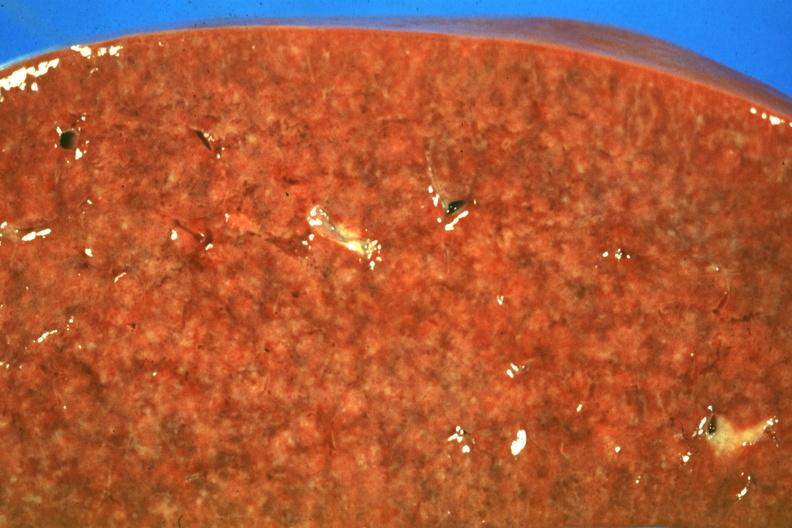does ameloblastoma show cut surface granulomas faint but there?
Answer the question using a single word or phrase. No 